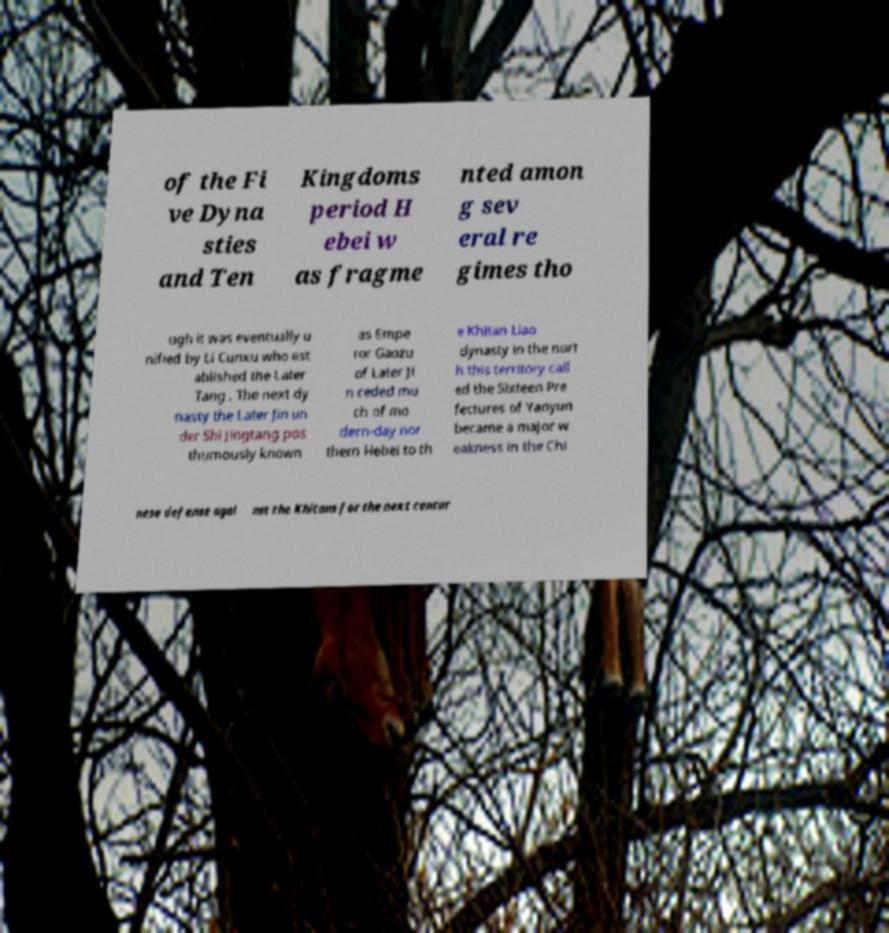Please identify and transcribe the text found in this image. of the Fi ve Dyna sties and Ten Kingdoms period H ebei w as fragme nted amon g sev eral re gimes tho ugh it was eventually u nified by Li Cunxu who est ablished the Later Tang . The next dy nasty the Later Jin un der Shi Jingtang pos thumously known as Empe ror Gaozu of Later Ji n ceded mu ch of mo dern-day nor thern Hebei to th e Khitan Liao dynasty in the nort h this territory call ed the Sixteen Pre fectures of Yanyun became a major w eakness in the Chi nese defense agai nst the Khitans for the next centur 